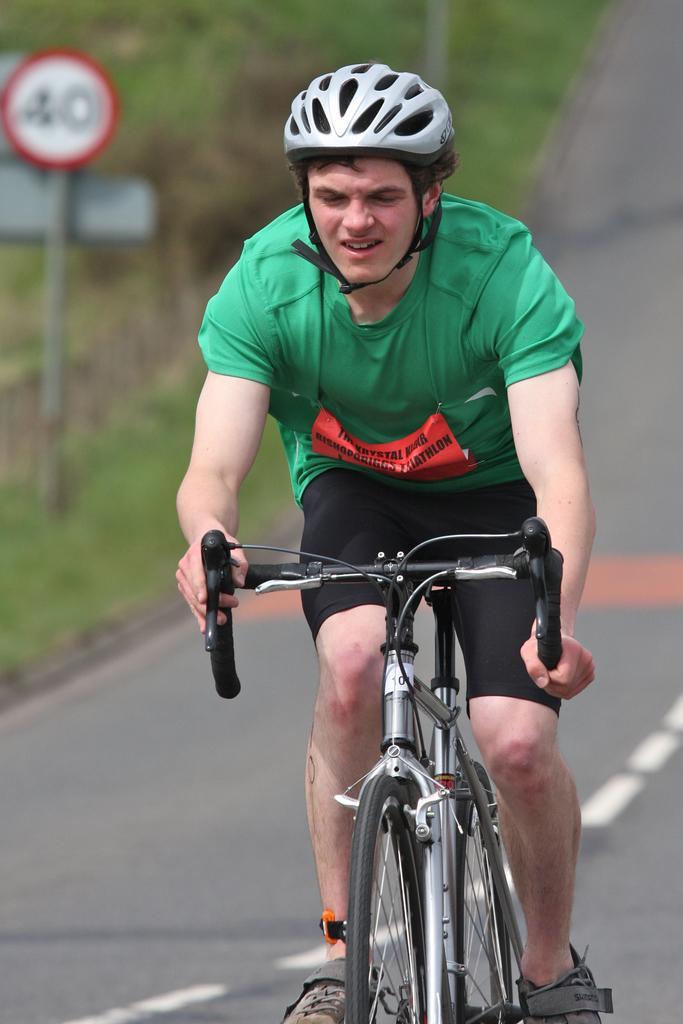In one or two sentences, can you explain what this image depicts? There is a man riding bicycle on road wearing helmet and green t shirt behind him there are lot of trees and a pole with a sign board. 